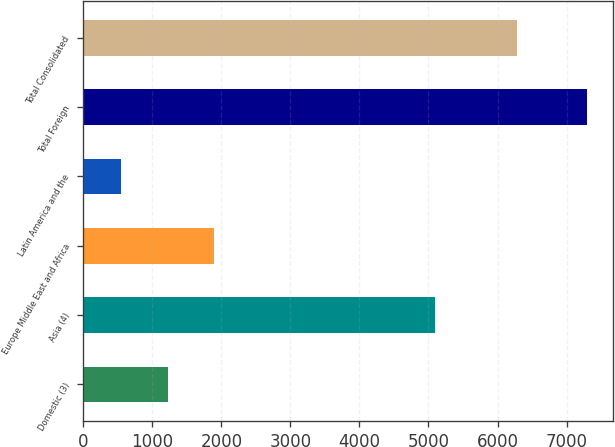<chart> <loc_0><loc_0><loc_500><loc_500><bar_chart><fcel>Domestic (3)<fcel>Asia (4)<fcel>Europe Middle East and Africa<fcel>Latin America and the<fcel>Total Foreign<fcel>Total Consolidated<nl><fcel>1223.3<fcel>5101<fcel>1898.6<fcel>548<fcel>7301<fcel>6276<nl></chart> 